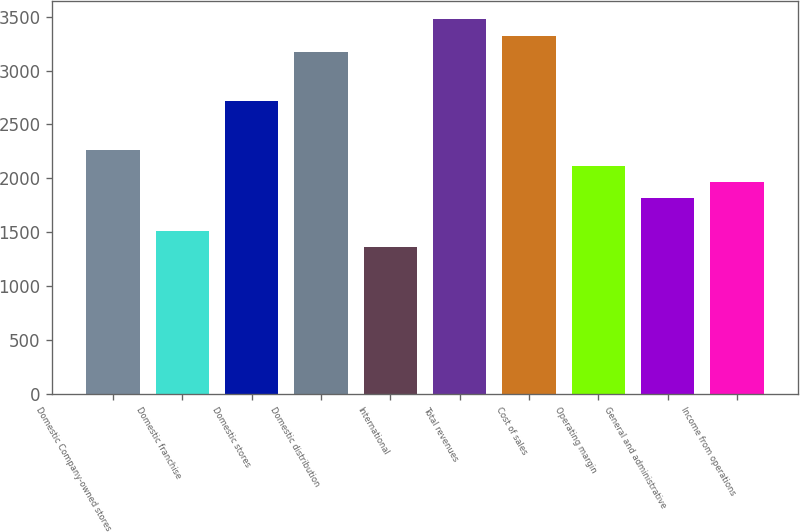Convert chart. <chart><loc_0><loc_0><loc_500><loc_500><bar_chart><fcel>Domestic Company-owned stores<fcel>Domestic franchise<fcel>Domestic stores<fcel>Domestic distribution<fcel>International<fcel>Total revenues<fcel>Cost of sales<fcel>Operating margin<fcel>General and administrative<fcel>Income from operations<nl><fcel>2267<fcel>1511.6<fcel>2720.24<fcel>3173.48<fcel>1360.52<fcel>3475.64<fcel>3324.56<fcel>2115.92<fcel>1813.76<fcel>1964.84<nl></chart> 